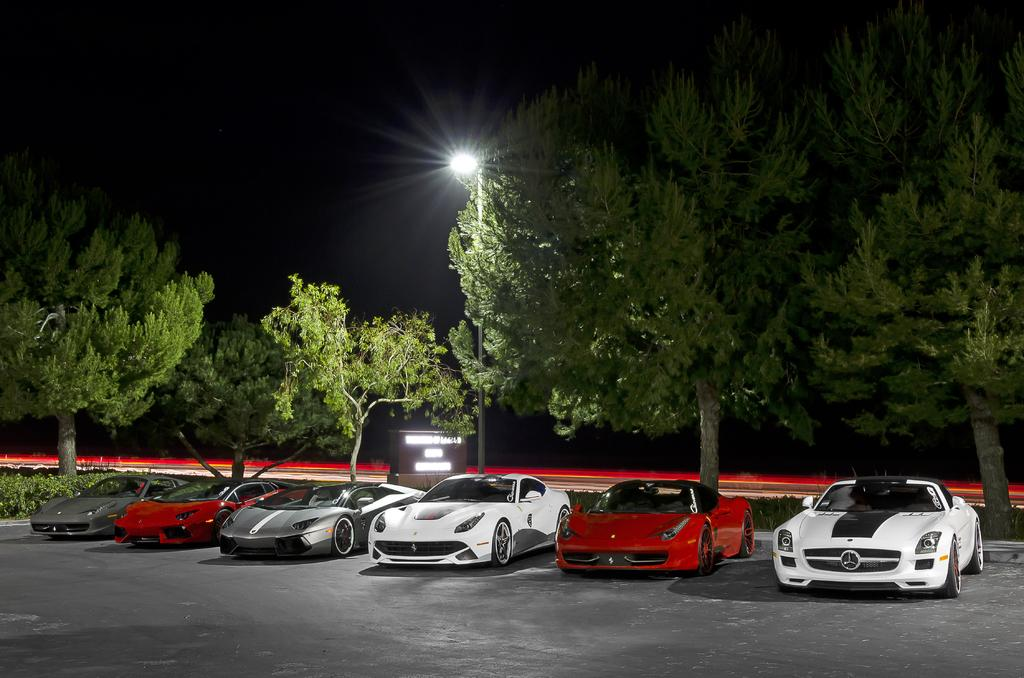What type of area is shown in the image? There is a parking area in the image. What can be seen in the parking area? Cars are parked in the parking area. What is located behind the parking area? There is a railing behind the parking area, and trees are visible behind the railing. What is the purpose of the pole in the image? There is a pole with a street light in the image, which provides illumination. Can you tell me how many passengers are flying on the wrist in the image? There are no passengers or wrists visible in the image; it features a parking area with cars, a railing, trees, and a street light. 